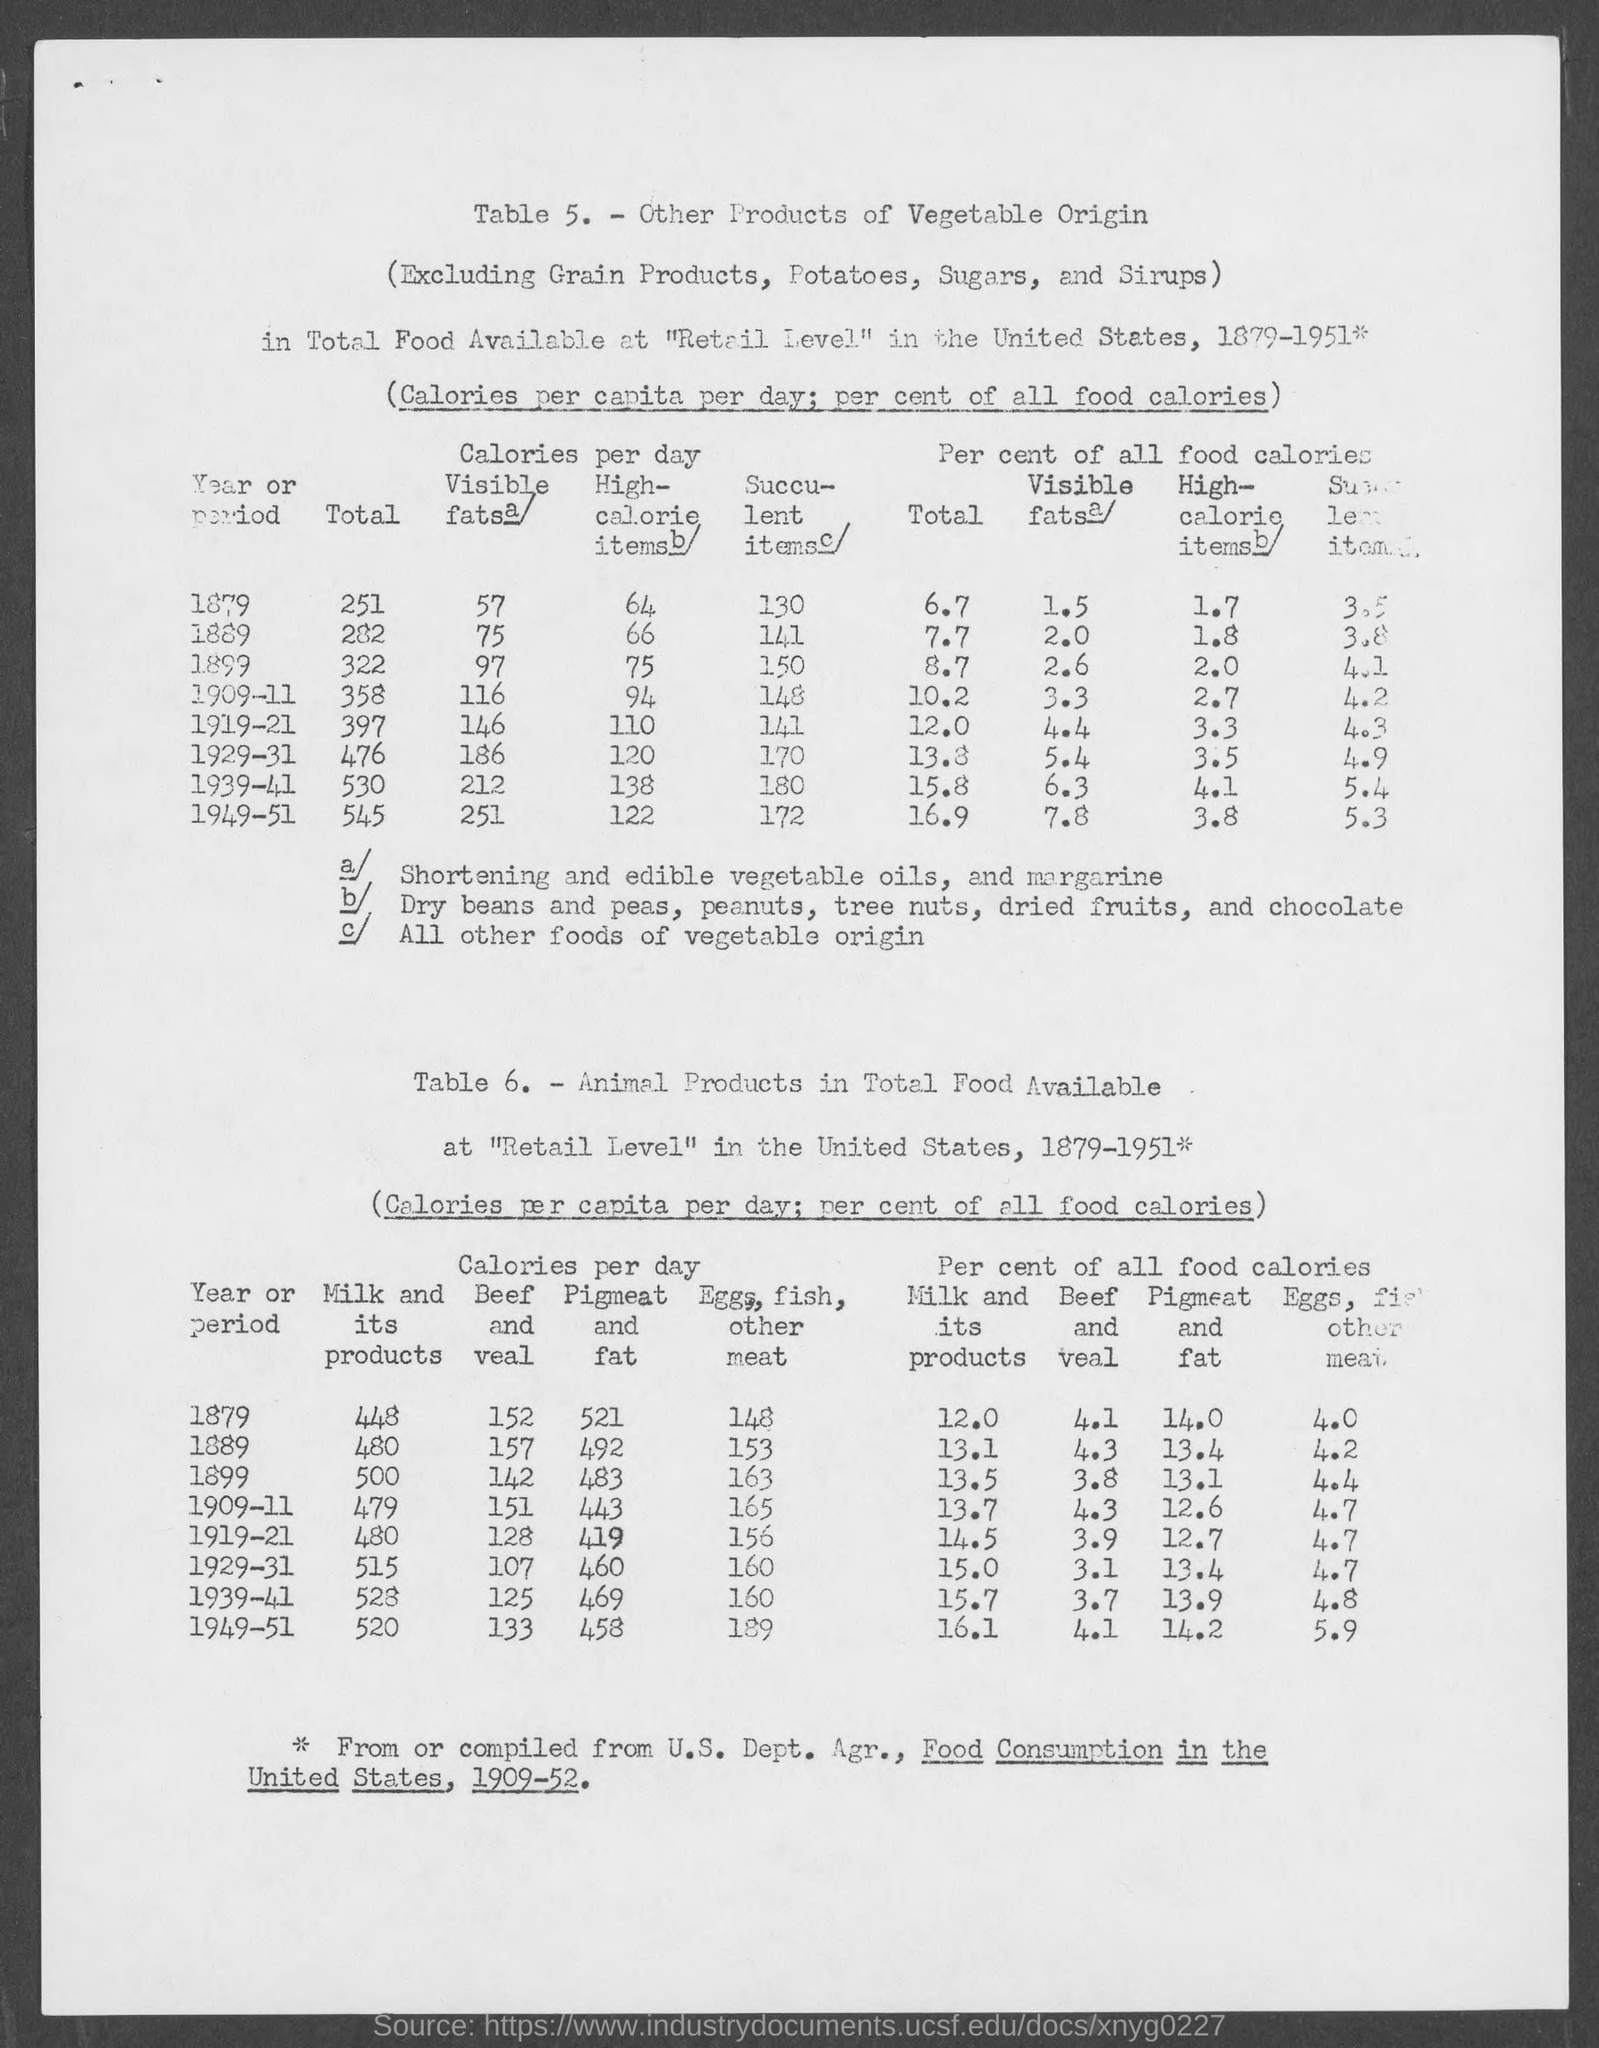Highlight a few significant elements in this photo. The number of the second table is Table 6. What is the number of the first table in the dataset? It is Table 5. 